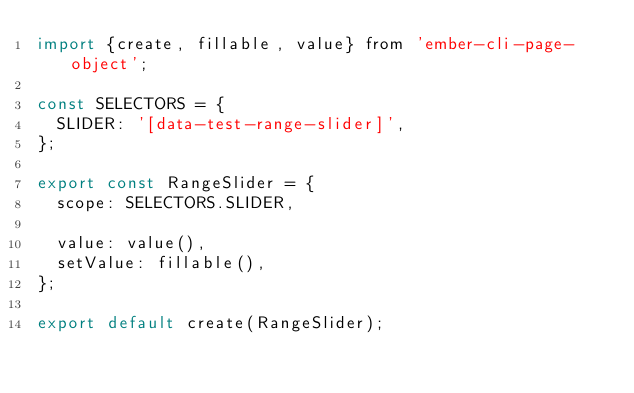Convert code to text. <code><loc_0><loc_0><loc_500><loc_500><_JavaScript_>import {create, fillable, value} from 'ember-cli-page-object';

const SELECTORS = {
  SLIDER: '[data-test-range-slider]',
};

export const RangeSlider = {
  scope: SELECTORS.SLIDER,

  value: value(),
  setValue: fillable(),
};

export default create(RangeSlider);
</code> 